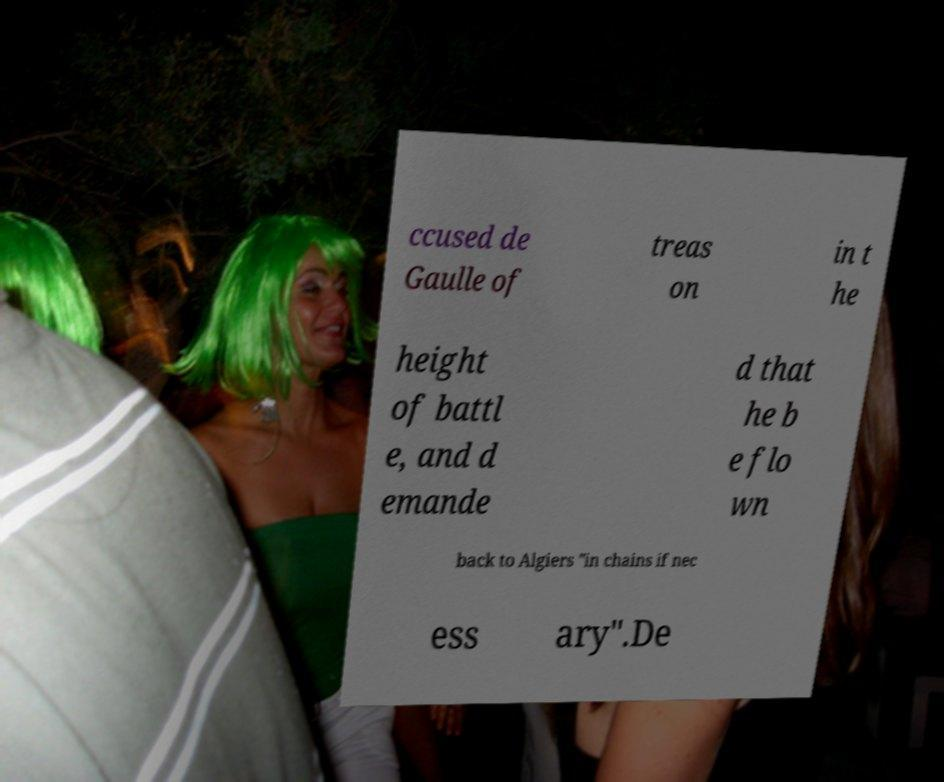I need the written content from this picture converted into text. Can you do that? ccused de Gaulle of treas on in t he height of battl e, and d emande d that he b e flo wn back to Algiers "in chains if nec ess ary".De 